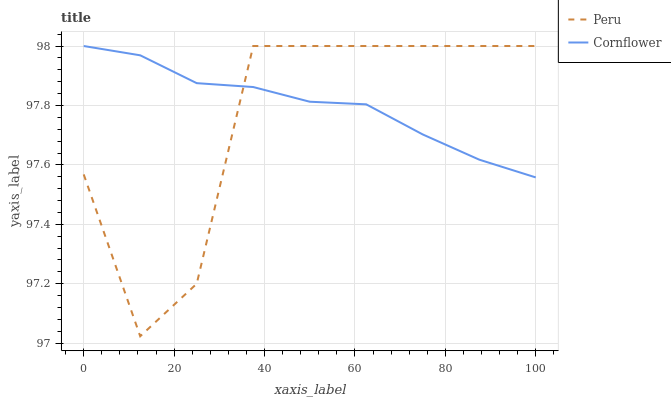Does Peru have the minimum area under the curve?
Answer yes or no. Yes. Does Cornflower have the maximum area under the curve?
Answer yes or no. Yes. Does Peru have the maximum area under the curve?
Answer yes or no. No. Is Cornflower the smoothest?
Answer yes or no. Yes. Is Peru the roughest?
Answer yes or no. Yes. Is Peru the smoothest?
Answer yes or no. No. Does Peru have the lowest value?
Answer yes or no. Yes. Does Peru have the highest value?
Answer yes or no. Yes. Does Cornflower intersect Peru?
Answer yes or no. Yes. Is Cornflower less than Peru?
Answer yes or no. No. Is Cornflower greater than Peru?
Answer yes or no. No. 